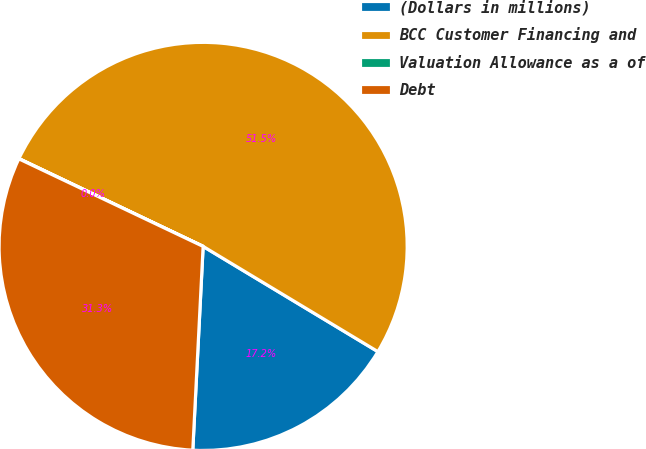<chart> <loc_0><loc_0><loc_500><loc_500><pie_chart><fcel>(Dollars in millions)<fcel>BCC Customer Financing and<fcel>Valuation Allowance as a of<fcel>Debt<nl><fcel>17.18%<fcel>51.54%<fcel>0.02%<fcel>31.25%<nl></chart> 